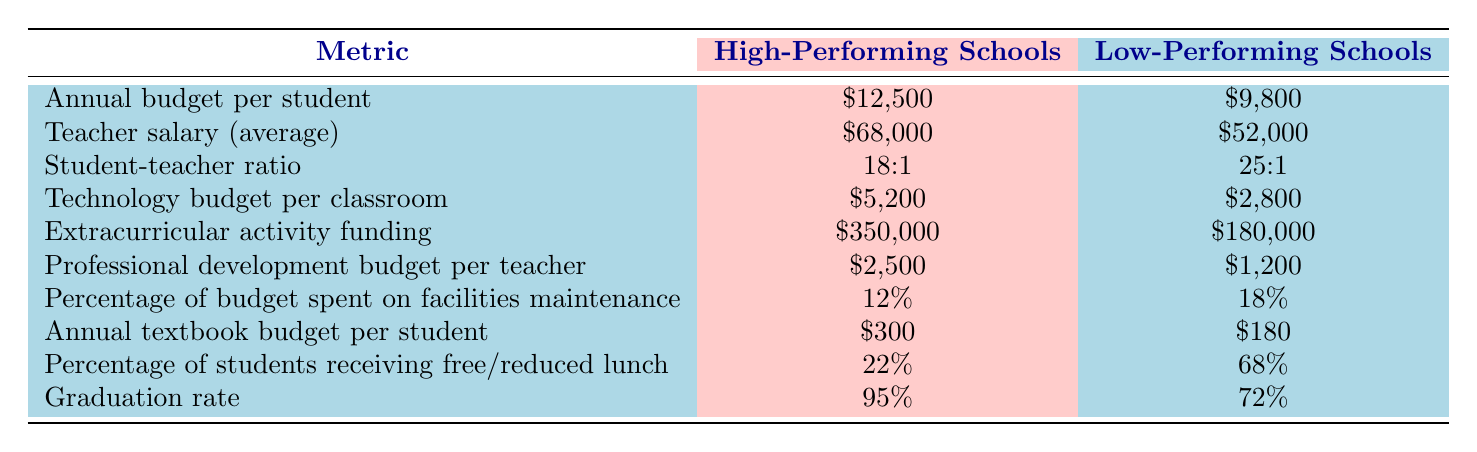What is the annual budget per student for high-performing schools? The table lists the annual budget per student for high-performing schools as $12,500.
Answer: $12,500 What is the average teacher salary in low-performing schools? According to the table, the average teacher salary in low-performing schools is $52,000.
Answer: $52,000 What is the student-teacher ratio in high-performing schools? The table indicates that the student-teacher ratio in high-performing schools is 18:1.
Answer: 18:1 How much more is spent on technology per classroom in high-performing schools compared to low-performing schools? To find the difference, subtract the technology budget per classroom for low-performing schools ($2,800) from that of high-performing schools ($5,200). This is $5,200 - $2,800 = $2,400.
Answer: $2,400 Does the percentage of students receiving free/reduced lunch in high-performing schools exceed 30%? The table shows that the percentage of students receiving free/reduced lunch in high-performing schools is 22%, which does not exceed 30%.
Answer: No What is the combined funding for extracurricular activities in both high and low-performing schools? To find the total funding for extracurricular activities, add the funding for high-performing schools ($350,000) and low-performing schools ($180,000). This gives $350,000 + $180,000 = $530,000.
Answer: $530,000 What percentage of the budget is spent on facilities maintenance in low-performing schools? The table states that low-performing schools spend 18% of their budget on facilities maintenance.
Answer: 18% What is the difference in graduation rates between low-performing and high-performing schools? The graduation rate for high-performing schools is 95% and for low-performing schools, it is 72%. The difference is calculated as 95% - 72% = 23%.
Answer: 23% What is the average professional development budget per teacher in high-performing schools compared to low-performing schools? The average professional development budget per teacher in high-performing schools is $2,500, while in low-performing schools it is $1,200. The difference is $2,500 - $1,200 = $1,300, indicating higher investment in high-performing schools.
Answer: $1,300 Is the technology budget per classroom in low-performing schools less than $3,000? The technology budget per classroom in low-performing schools is $2,800, which is indeed less than $3,000.
Answer: Yes 